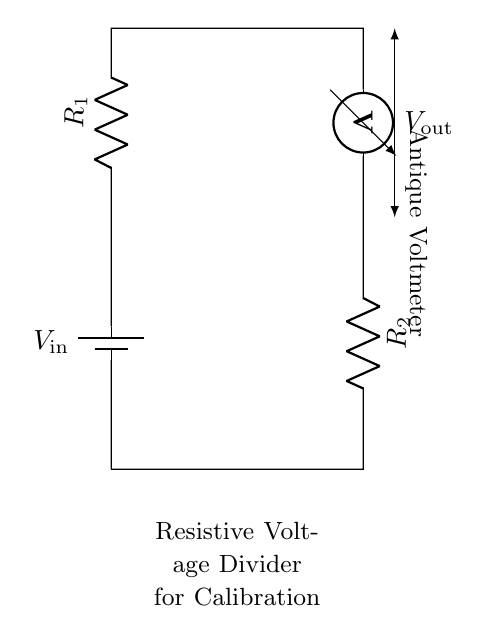What is the input voltage of the circuit? The input voltage is labeled as \( V_{\text{in}} \), which is denoted near the battery in the diagram.
Answer: \( V_{\text{in}} \) What type of meter is used in the circuit? The diagram shows a voltmeter labeled as "Antique Voltmeter", indicating it is used to measure voltage specifically.
Answer: Antique Voltmeter How many resistors are present in this voltage divider? The circuit diagram includes two resistors \( R_1 \) and \( R_2 \), identified by their labels in the diagram.
Answer: 2 What is the output voltage taken from? The output voltage \( V_{\text{out}} \) is taken from the connection point where \( R_2 \) and the voltmeter meet, as indicated by the notation in the circuit.
Answer: Voltmeter connection What is the purpose of this circuit? The resistive voltage divider is specifically mentioned as being for calibration, meaning it is used to set a standard for measuring instruments like voltmeters.
Answer: Calibration What happens to the voltage across \( R_2 \)? The voltage across \( R_2 \) is the output voltage \( V_{\text{out}} \), which is derived from the division of \( V_{\text{in}} \) by the resistors in the circuit based on their values.
Answer: \( V_{\text{out}} \) What would happen if \( R_1 \) is increased? Increasing \( R_1 \) would result in a larger voltage drop across \( R_1 \), leading to a lower output voltage \( V_{\text{out}} \), as dictated by the voltage divider principle.
Answer: Lower output voltage 